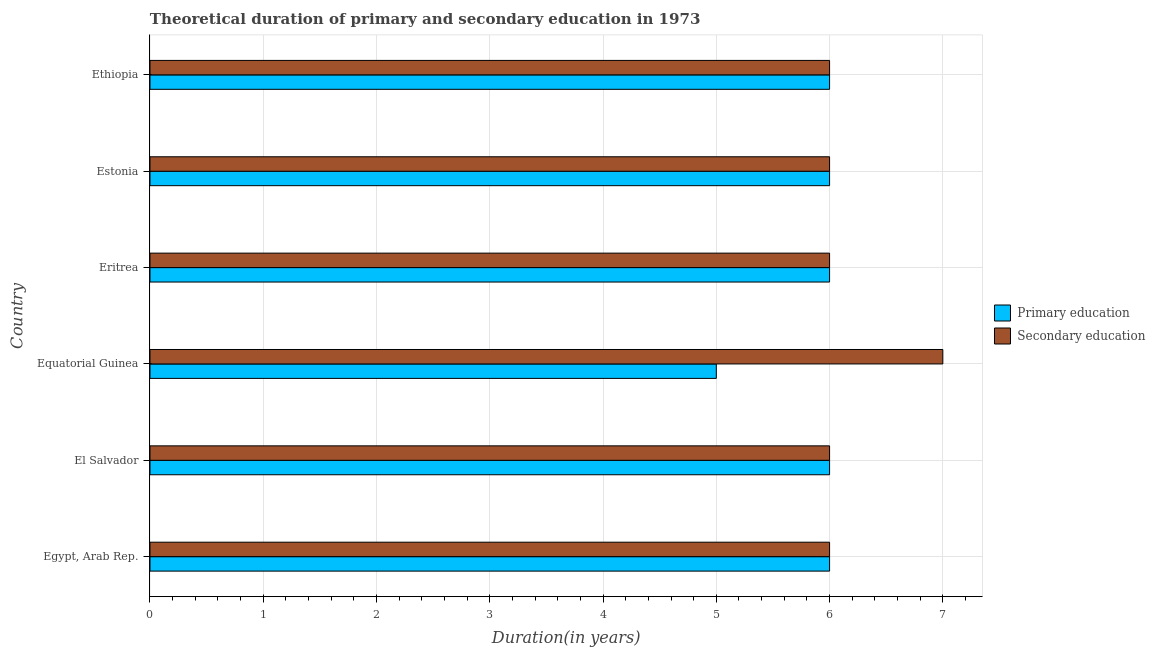How many different coloured bars are there?
Keep it short and to the point. 2. How many bars are there on the 1st tick from the top?
Give a very brief answer. 2. What is the label of the 4th group of bars from the top?
Offer a terse response. Equatorial Guinea. In how many cases, is the number of bars for a given country not equal to the number of legend labels?
Make the answer very short. 0. What is the duration of primary education in Equatorial Guinea?
Offer a very short reply. 5. Across all countries, what is the maximum duration of primary education?
Provide a short and direct response. 6. Across all countries, what is the minimum duration of primary education?
Make the answer very short. 5. In which country was the duration of primary education maximum?
Keep it short and to the point. Egypt, Arab Rep. In which country was the duration of primary education minimum?
Your response must be concise. Equatorial Guinea. What is the total duration of secondary education in the graph?
Offer a very short reply. 37. What is the difference between the duration of secondary education in Egypt, Arab Rep. and that in Ethiopia?
Offer a very short reply. 0. What is the difference between the duration of primary education in Ethiopia and the duration of secondary education in El Salvador?
Ensure brevity in your answer.  0. What is the average duration of primary education per country?
Offer a very short reply. 5.83. In how many countries, is the duration of secondary education greater than 5 years?
Give a very brief answer. 6. What is the difference between the highest and the lowest duration of secondary education?
Make the answer very short. 1. What does the 1st bar from the top in El Salvador represents?
Give a very brief answer. Secondary education. What does the 2nd bar from the bottom in Ethiopia represents?
Your response must be concise. Secondary education. How many bars are there?
Provide a succinct answer. 12. Are all the bars in the graph horizontal?
Your answer should be compact. Yes. Does the graph contain any zero values?
Your response must be concise. No. Does the graph contain grids?
Keep it short and to the point. Yes. How many legend labels are there?
Provide a succinct answer. 2. What is the title of the graph?
Keep it short and to the point. Theoretical duration of primary and secondary education in 1973. What is the label or title of the X-axis?
Give a very brief answer. Duration(in years). What is the label or title of the Y-axis?
Your response must be concise. Country. What is the Duration(in years) in Primary education in El Salvador?
Your answer should be compact. 6. What is the Duration(in years) of Secondary education in El Salvador?
Offer a terse response. 6. What is the Duration(in years) in Primary education in Equatorial Guinea?
Make the answer very short. 5. What is the Duration(in years) of Primary education in Eritrea?
Your response must be concise. 6. What is the Duration(in years) of Secondary education in Ethiopia?
Your answer should be compact. 6. Across all countries, what is the maximum Duration(in years) in Primary education?
Your answer should be compact. 6. Across all countries, what is the minimum Duration(in years) of Primary education?
Offer a very short reply. 5. Across all countries, what is the minimum Duration(in years) in Secondary education?
Offer a terse response. 6. What is the total Duration(in years) in Secondary education in the graph?
Keep it short and to the point. 37. What is the difference between the Duration(in years) in Primary education in Egypt, Arab Rep. and that in El Salvador?
Give a very brief answer. 0. What is the difference between the Duration(in years) of Primary education in Egypt, Arab Rep. and that in Eritrea?
Your response must be concise. 0. What is the difference between the Duration(in years) in Secondary education in Egypt, Arab Rep. and that in Eritrea?
Your response must be concise. 0. What is the difference between the Duration(in years) of Primary education in Egypt, Arab Rep. and that in Estonia?
Ensure brevity in your answer.  0. What is the difference between the Duration(in years) of Secondary education in Egypt, Arab Rep. and that in Estonia?
Ensure brevity in your answer.  0. What is the difference between the Duration(in years) of Secondary education in El Salvador and that in Equatorial Guinea?
Offer a terse response. -1. What is the difference between the Duration(in years) in Secondary education in El Salvador and that in Eritrea?
Offer a very short reply. 0. What is the difference between the Duration(in years) of Secondary education in El Salvador and that in Estonia?
Offer a terse response. 0. What is the difference between the Duration(in years) of Primary education in El Salvador and that in Ethiopia?
Give a very brief answer. 0. What is the difference between the Duration(in years) in Secondary education in El Salvador and that in Ethiopia?
Ensure brevity in your answer.  0. What is the difference between the Duration(in years) in Primary education in Equatorial Guinea and that in Estonia?
Make the answer very short. -1. What is the difference between the Duration(in years) of Secondary education in Equatorial Guinea and that in Ethiopia?
Provide a succinct answer. 1. What is the difference between the Duration(in years) in Primary education in Eritrea and that in Estonia?
Give a very brief answer. 0. What is the difference between the Duration(in years) of Secondary education in Eritrea and that in Ethiopia?
Your answer should be compact. 0. What is the difference between the Duration(in years) of Primary education in Estonia and that in Ethiopia?
Your answer should be compact. 0. What is the difference between the Duration(in years) of Primary education in Egypt, Arab Rep. and the Duration(in years) of Secondary education in El Salvador?
Provide a succinct answer. 0. What is the difference between the Duration(in years) in Primary education in Egypt, Arab Rep. and the Duration(in years) in Secondary education in Estonia?
Make the answer very short. 0. What is the difference between the Duration(in years) in Primary education in El Salvador and the Duration(in years) in Secondary education in Equatorial Guinea?
Offer a terse response. -1. What is the difference between the Duration(in years) of Primary education in El Salvador and the Duration(in years) of Secondary education in Ethiopia?
Provide a succinct answer. 0. What is the difference between the Duration(in years) in Primary education in Equatorial Guinea and the Duration(in years) in Secondary education in Estonia?
Provide a succinct answer. -1. What is the difference between the Duration(in years) of Primary education in Equatorial Guinea and the Duration(in years) of Secondary education in Ethiopia?
Your response must be concise. -1. What is the difference between the Duration(in years) in Primary education in Eritrea and the Duration(in years) in Secondary education in Estonia?
Your response must be concise. 0. What is the difference between the Duration(in years) in Primary education in Eritrea and the Duration(in years) in Secondary education in Ethiopia?
Your answer should be compact. 0. What is the difference between the Duration(in years) of Primary education in Estonia and the Duration(in years) of Secondary education in Ethiopia?
Provide a succinct answer. 0. What is the average Duration(in years) in Primary education per country?
Your response must be concise. 5.83. What is the average Duration(in years) in Secondary education per country?
Your response must be concise. 6.17. What is the difference between the Duration(in years) of Primary education and Duration(in years) of Secondary education in El Salvador?
Offer a very short reply. 0. What is the difference between the Duration(in years) of Primary education and Duration(in years) of Secondary education in Eritrea?
Keep it short and to the point. 0. What is the difference between the Duration(in years) of Primary education and Duration(in years) of Secondary education in Estonia?
Make the answer very short. 0. What is the difference between the Duration(in years) of Primary education and Duration(in years) of Secondary education in Ethiopia?
Ensure brevity in your answer.  0. What is the ratio of the Duration(in years) of Primary education in Egypt, Arab Rep. to that in El Salvador?
Keep it short and to the point. 1. What is the ratio of the Duration(in years) of Primary education in Egypt, Arab Rep. to that in Equatorial Guinea?
Provide a succinct answer. 1.2. What is the ratio of the Duration(in years) in Secondary education in Egypt, Arab Rep. to that in Eritrea?
Offer a terse response. 1. What is the ratio of the Duration(in years) in Primary education in Egypt, Arab Rep. to that in Estonia?
Provide a succinct answer. 1. What is the ratio of the Duration(in years) of Secondary education in Egypt, Arab Rep. to that in Estonia?
Provide a short and direct response. 1. What is the ratio of the Duration(in years) in Secondary education in Egypt, Arab Rep. to that in Ethiopia?
Give a very brief answer. 1. What is the ratio of the Duration(in years) in Secondary education in El Salvador to that in Equatorial Guinea?
Offer a very short reply. 0.86. What is the ratio of the Duration(in years) of Primary education in El Salvador to that in Eritrea?
Provide a succinct answer. 1. What is the ratio of the Duration(in years) of Secondary education in El Salvador to that in Eritrea?
Provide a succinct answer. 1. What is the ratio of the Duration(in years) of Secondary education in El Salvador to that in Estonia?
Your answer should be very brief. 1. What is the ratio of the Duration(in years) of Primary education in El Salvador to that in Ethiopia?
Ensure brevity in your answer.  1. What is the ratio of the Duration(in years) of Primary education in Equatorial Guinea to that in Eritrea?
Provide a short and direct response. 0.83. What is the ratio of the Duration(in years) of Secondary education in Equatorial Guinea to that in Estonia?
Provide a succinct answer. 1.17. What is the ratio of the Duration(in years) in Secondary education in Equatorial Guinea to that in Ethiopia?
Offer a terse response. 1.17. What is the ratio of the Duration(in years) in Primary education in Eritrea to that in Estonia?
Your answer should be compact. 1. What is the ratio of the Duration(in years) of Secondary education in Eritrea to that in Estonia?
Your response must be concise. 1. What is the ratio of the Duration(in years) of Primary education in Eritrea to that in Ethiopia?
Your response must be concise. 1. What is the ratio of the Duration(in years) of Secondary education in Eritrea to that in Ethiopia?
Your response must be concise. 1. What is the ratio of the Duration(in years) in Secondary education in Estonia to that in Ethiopia?
Your response must be concise. 1. What is the difference between the highest and the lowest Duration(in years) of Secondary education?
Ensure brevity in your answer.  1. 